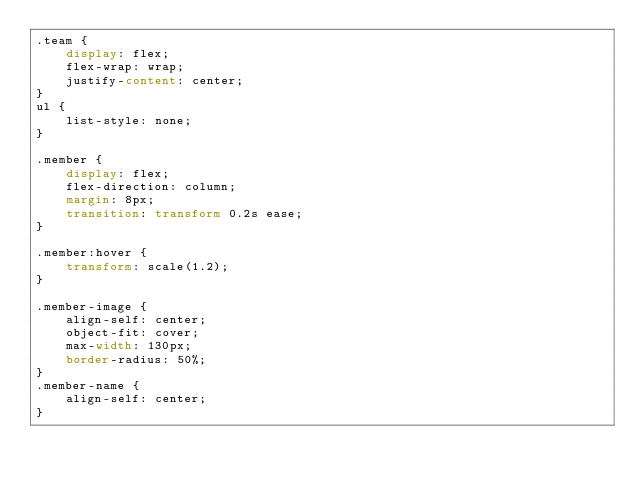<code> <loc_0><loc_0><loc_500><loc_500><_CSS_>.team {
    display: flex;
    flex-wrap: wrap;
    justify-content: center;
}
ul {
    list-style: none;
}

.member {
    display: flex;
    flex-direction: column;
    margin: 8px;
    transition: transform 0.2s ease;
}

.member:hover {
    transform: scale(1.2);
}

.member-image {
    align-self: center;
    object-fit: cover;
    max-width: 130px;
    border-radius: 50%;
}
.member-name {
    align-self: center;
}
</code> 